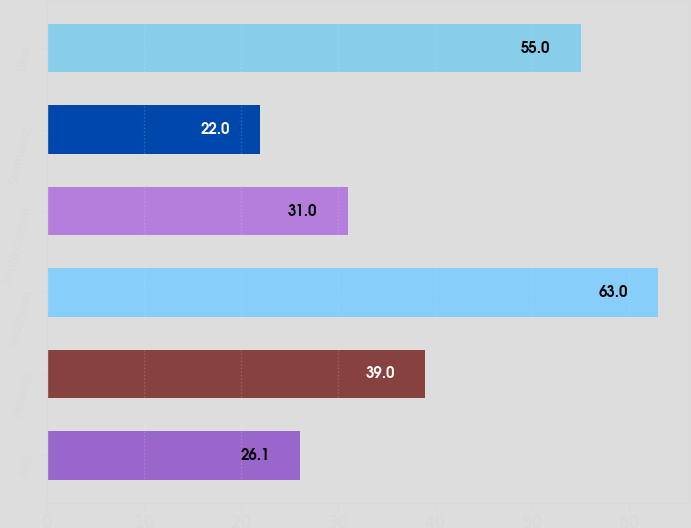<chart> <loc_0><loc_0><loc_500><loc_500><bar_chart><fcel>East<fcel>Midwest<fcel>Southeast<fcel>South Central<fcel>Southwest<fcel>West<nl><fcel>26.1<fcel>39<fcel>63<fcel>31<fcel>22<fcel>55<nl></chart> 